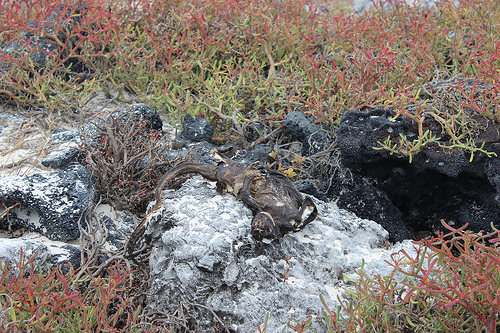<image>
Can you confirm if the rock is in front of the plant? No. The rock is not in front of the plant. The spatial positioning shows a different relationship between these objects. 